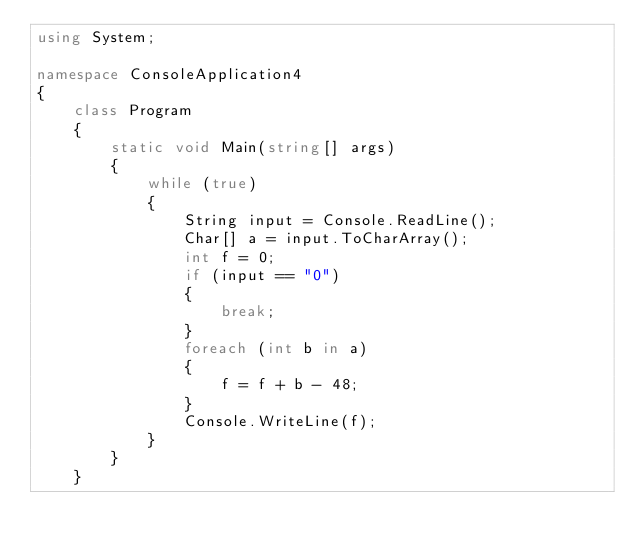Convert code to text. <code><loc_0><loc_0><loc_500><loc_500><_C#_>using System;

namespace ConsoleApplication4
{
    class Program
    {
        static void Main(string[] args)
        {
            while (true)
            {
                String input = Console.ReadLine();
                Char[] a = input.ToCharArray();
                int f = 0;
                if (input == "0")
                {
                    break;
                }
                foreach (int b in a)
                {
                    f = f + b - 48;
                }
                Console.WriteLine(f);
            }
        }
    }</code> 